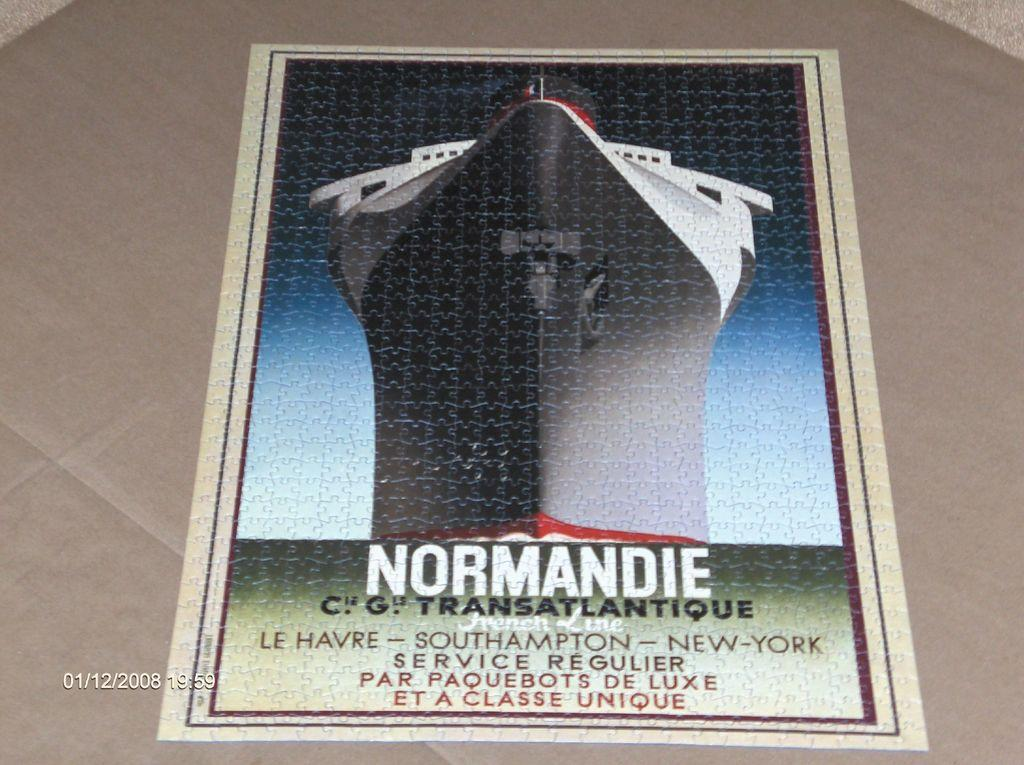<image>
Summarize the visual content of the image. A poster with a huge ship on it that says Normandie. 